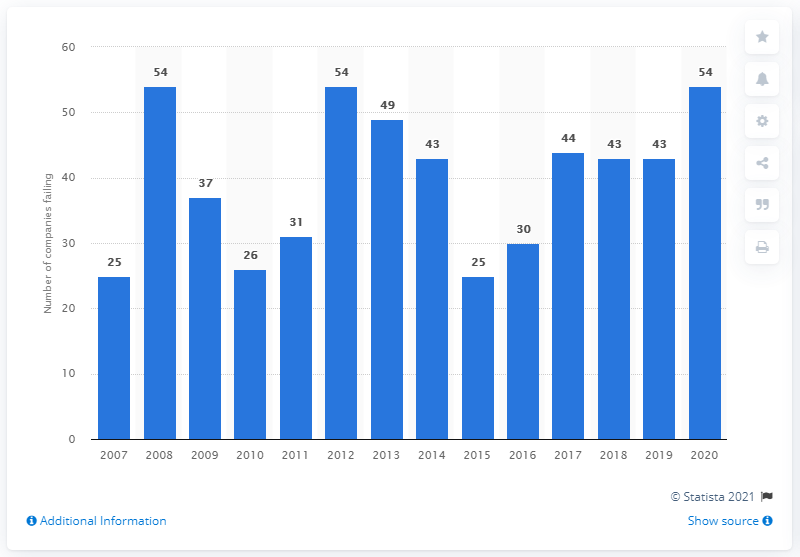Specify some key components in this picture. In 2020, a total of 54 retailers in the UK entered into receivership. 